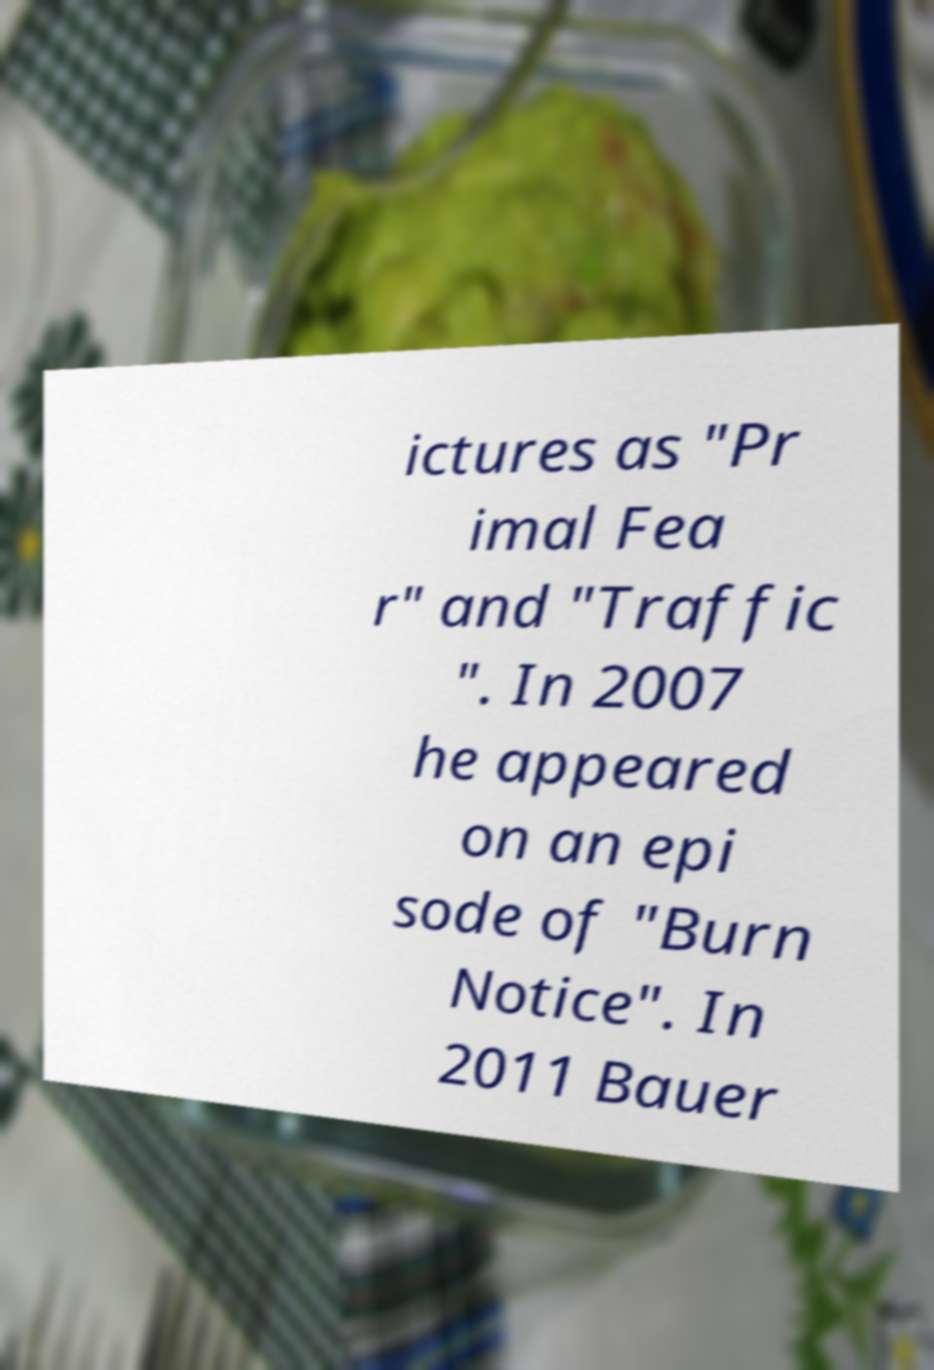I need the written content from this picture converted into text. Can you do that? ictures as "Pr imal Fea r" and "Traffic ". In 2007 he appeared on an epi sode of "Burn Notice". In 2011 Bauer 